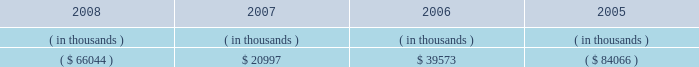Entergy mississippi , inc .
Management's financial discussion and analysis sources of capital entergy mississippi's sources to meet its capital requirements include : internally generated funds ; cash on hand ; debt or preferred stock issuances ; and bank financing under new or existing facilities .
Entergy mississippi may refinance or redeem debt and preferred stock prior to maturity , to the extent market conditions and interest and dividend rates are favorable .
All debt and common and preferred stock issuances by entergy mississippi require prior regulatory approval .
Preferred stock and debt issuances are also subject to issuance tests set forth in its corporate charter , bond indenture , and other agreements .
Entergy mississippi has sufficient capacity under these tests to meet its foreseeable capital needs .
Entergy mississippi has two separate credit facilities in the aggregate amount of $ 50 million and renewed both facilities through may 2009 .
Borrowings under the credit facilities may be secured by a security interest in entergy mississippi's accounts receivable .
No borrowings were outstanding under either credit facility as of december 31 , 2008 .
Entergy mississippi has obtained short-term borrowing authorization from the ferc under which it may borrow through march 31 , 2010 , up to the aggregate amount , at any one time outstanding , of $ 175 million .
See note 4 to the financial statements for further discussion of entergy mississippi's short-term borrowing limits .
Entergy mississippi has also obtained an order from the ferc authorizing long-term securities issuances .
The current long-term authorization extends through june 30 , 2009 .
Entergy mississippi's receivables from or ( payables to ) the money pool were as follows as of december 31 for each of the following years: .
In may 2007 , $ 6.6 million of entergy mississippi's receivable from the money pool was replaced by a note receivable from entergy new orleans .
See note 4 to the financial statements for a description of the money pool .
State and local rate regulation the rates that entergy mississippi charges for electricity significantly influence its financial position , results of operations , and liquidity .
Entergy mississippi is regulated and the rates charged to its customers are determined in regulatory proceedings .
A governmental agency , the mpsc , is primarily responsible for approval of the rates charged to customers .
Formula rate plan in march 2008 , entergy mississippi made its annual scheduled formula rate plan filing for the 2007 test year with the mpsc .
The filing showed that a $ 10.1 million increase in annual electric revenues is warranted .
In june 2008 , entergy mississippi reached a settlement with the mississippi public utilities staff that would result in a $ 3.8 million rate increase .
In january 2009 the mpsc rejected the settlement and left the current rates in effect .
Entergy mississippi appealed the mpsc's decision to the mississippi supreme court. .
How is the cash flow of entergy mississippi affected by the balance in money pool from 2007 to 2008? 
Computations: (20997 + 66044)
Answer: 87041.0. 